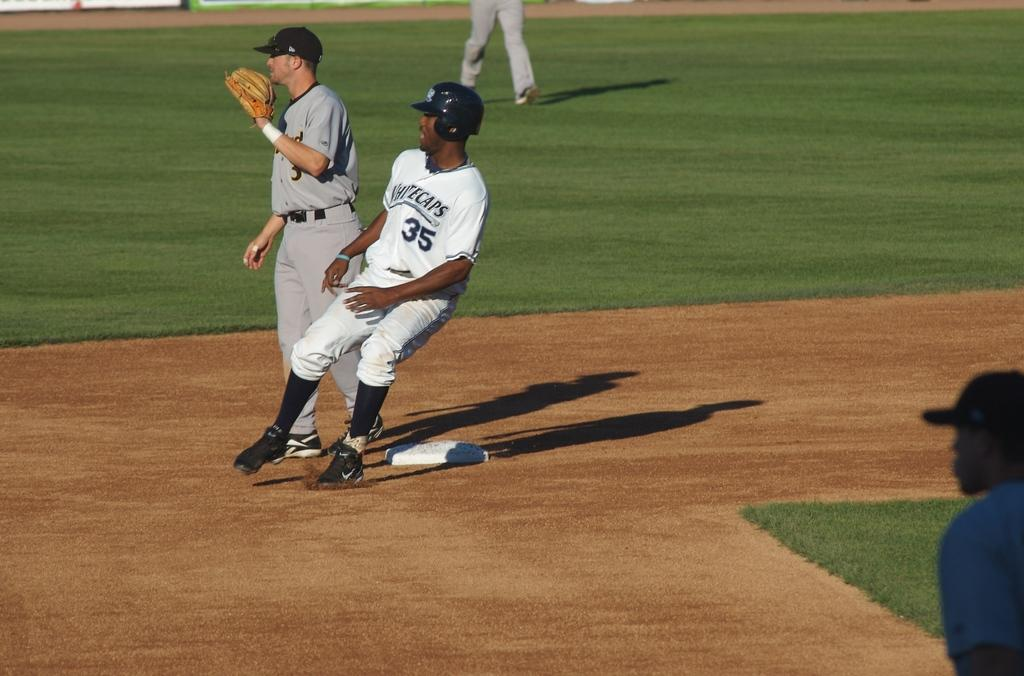<image>
Provide a brief description of the given image. A black man in a Whitecaps baseball uniform is at a base. 